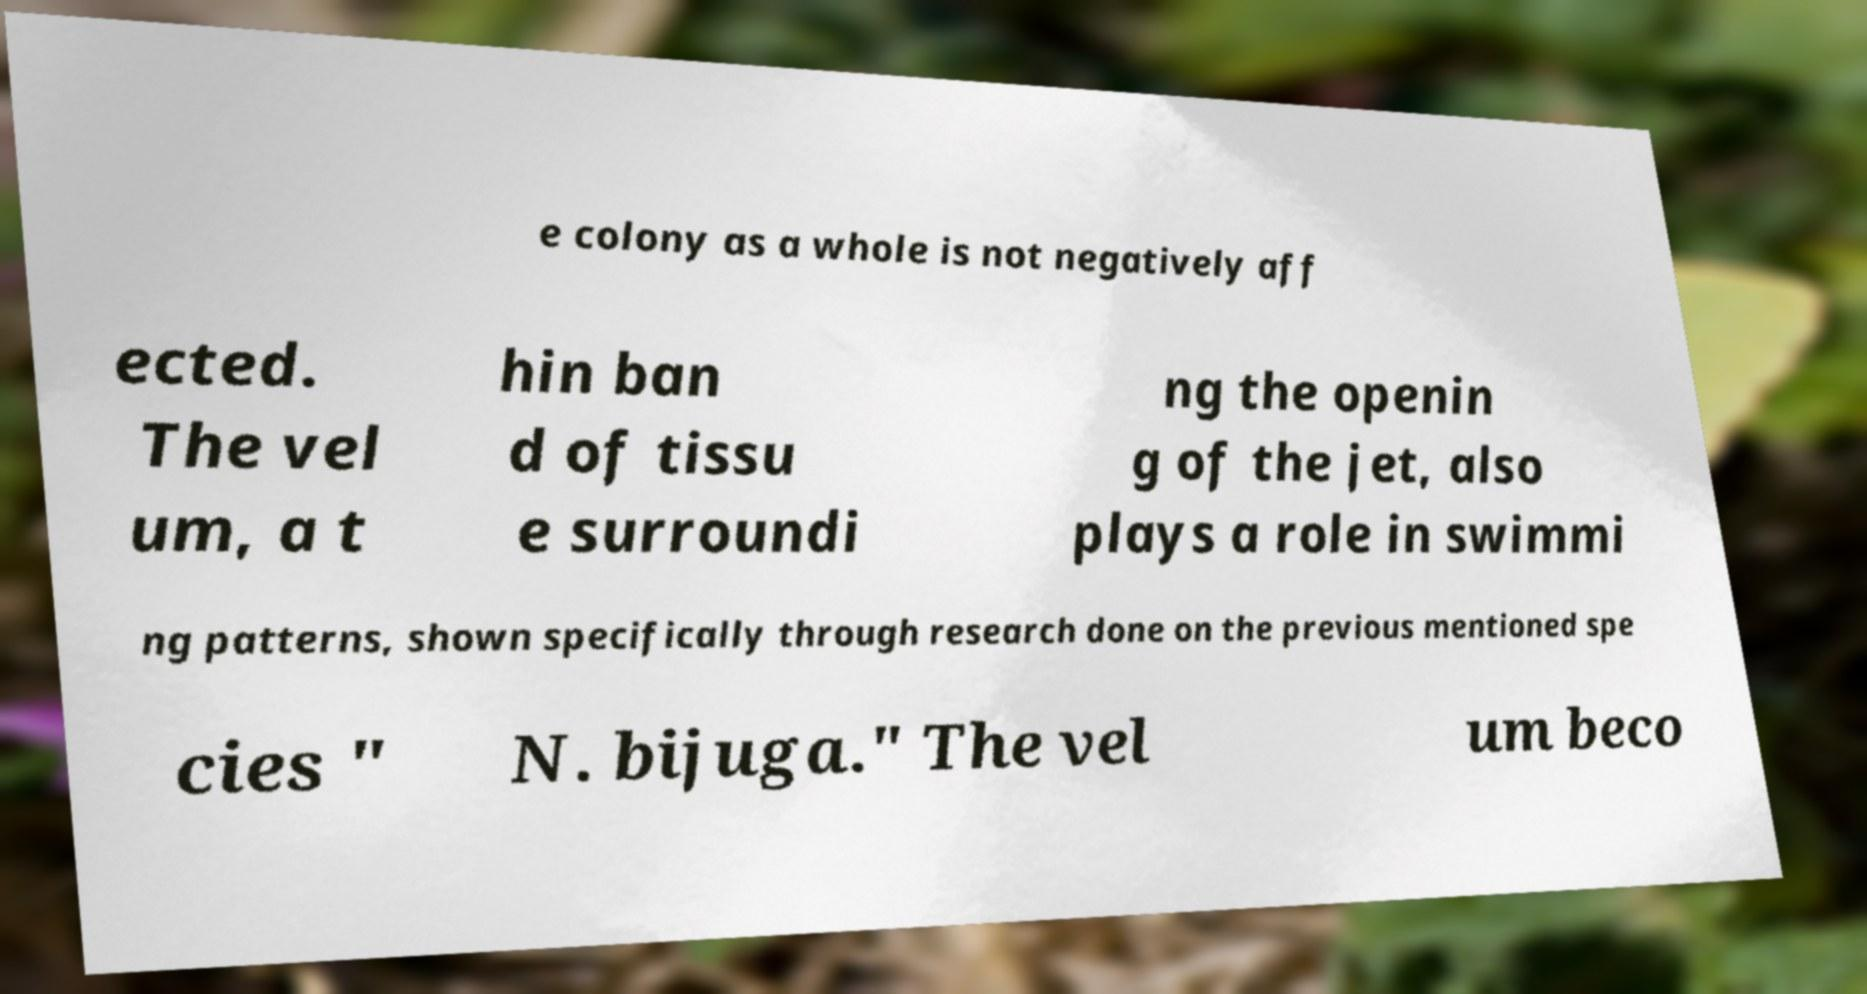For documentation purposes, I need the text within this image transcribed. Could you provide that? e colony as a whole is not negatively aff ected. The vel um, a t hin ban d of tissu e surroundi ng the openin g of the jet, also plays a role in swimmi ng patterns, shown specifically through research done on the previous mentioned spe cies " N. bijuga." The vel um beco 